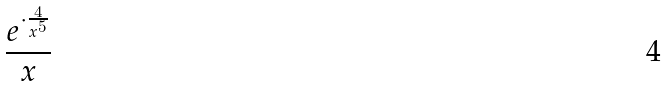Convert formula to latex. <formula><loc_0><loc_0><loc_500><loc_500>\frac { e ^ { \cdot \frac { 4 } { x ^ { 5 } } } } { x }</formula> 